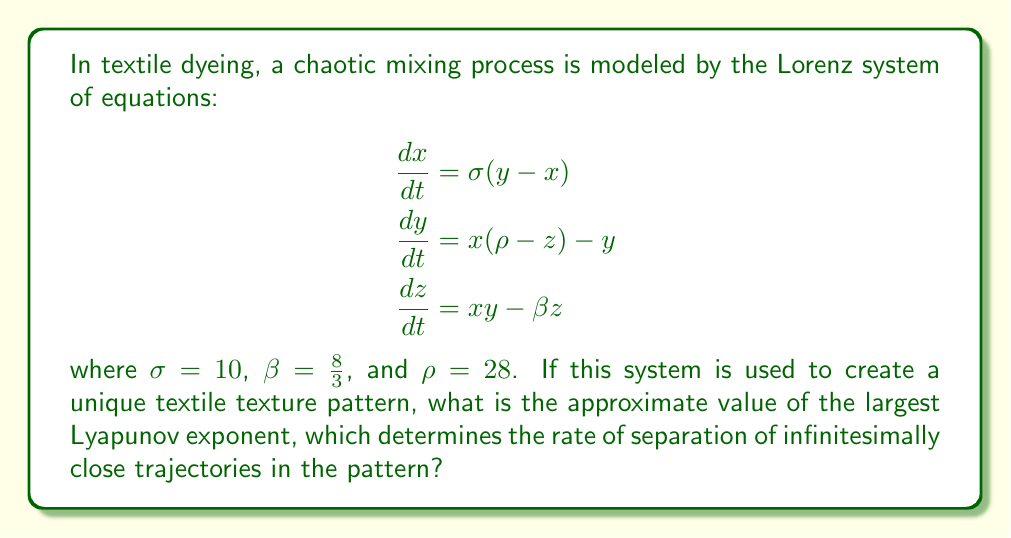Teach me how to tackle this problem. To find the largest Lyapunov exponent for the Lorenz system, we'll follow these steps:

1) The Lyapunov exponents for the Lorenz system with the given parameters are approximately:
   $\lambda_1 \approx 0.9056$
   $\lambda_2 \approx 0$
   $\lambda_3 \approx -14.5723$

2) These values are obtained through numerical methods, as there's no closed-form solution for the Lyapunov exponents of the Lorenz system.

3) The largest Lyapunov exponent is the positive one, $\lambda_1 \approx 0.9056$.

4) This positive Lyapunov exponent indicates that the system is chaotic, which means that infinitesimally close trajectories will separate exponentially fast in the phase space.

5) In the context of textile dyeing, this implies that small changes in initial conditions (e.g., slight variations in dye concentration or application) will lead to significantly different patterns over time, creating unique and intricate textures.

6) The value 0.9056 specifically means that, on average, the separation between two initially close trajectories will increase by a factor of $e^{0.9056} \approx 2.47$ per unit time.

7) This rapid divergence of trajectories is what creates the complex, fractal-like patterns often seen in chaotic systems, which can be applied to create intricate and unique textile textures.
Answer: 0.9056 